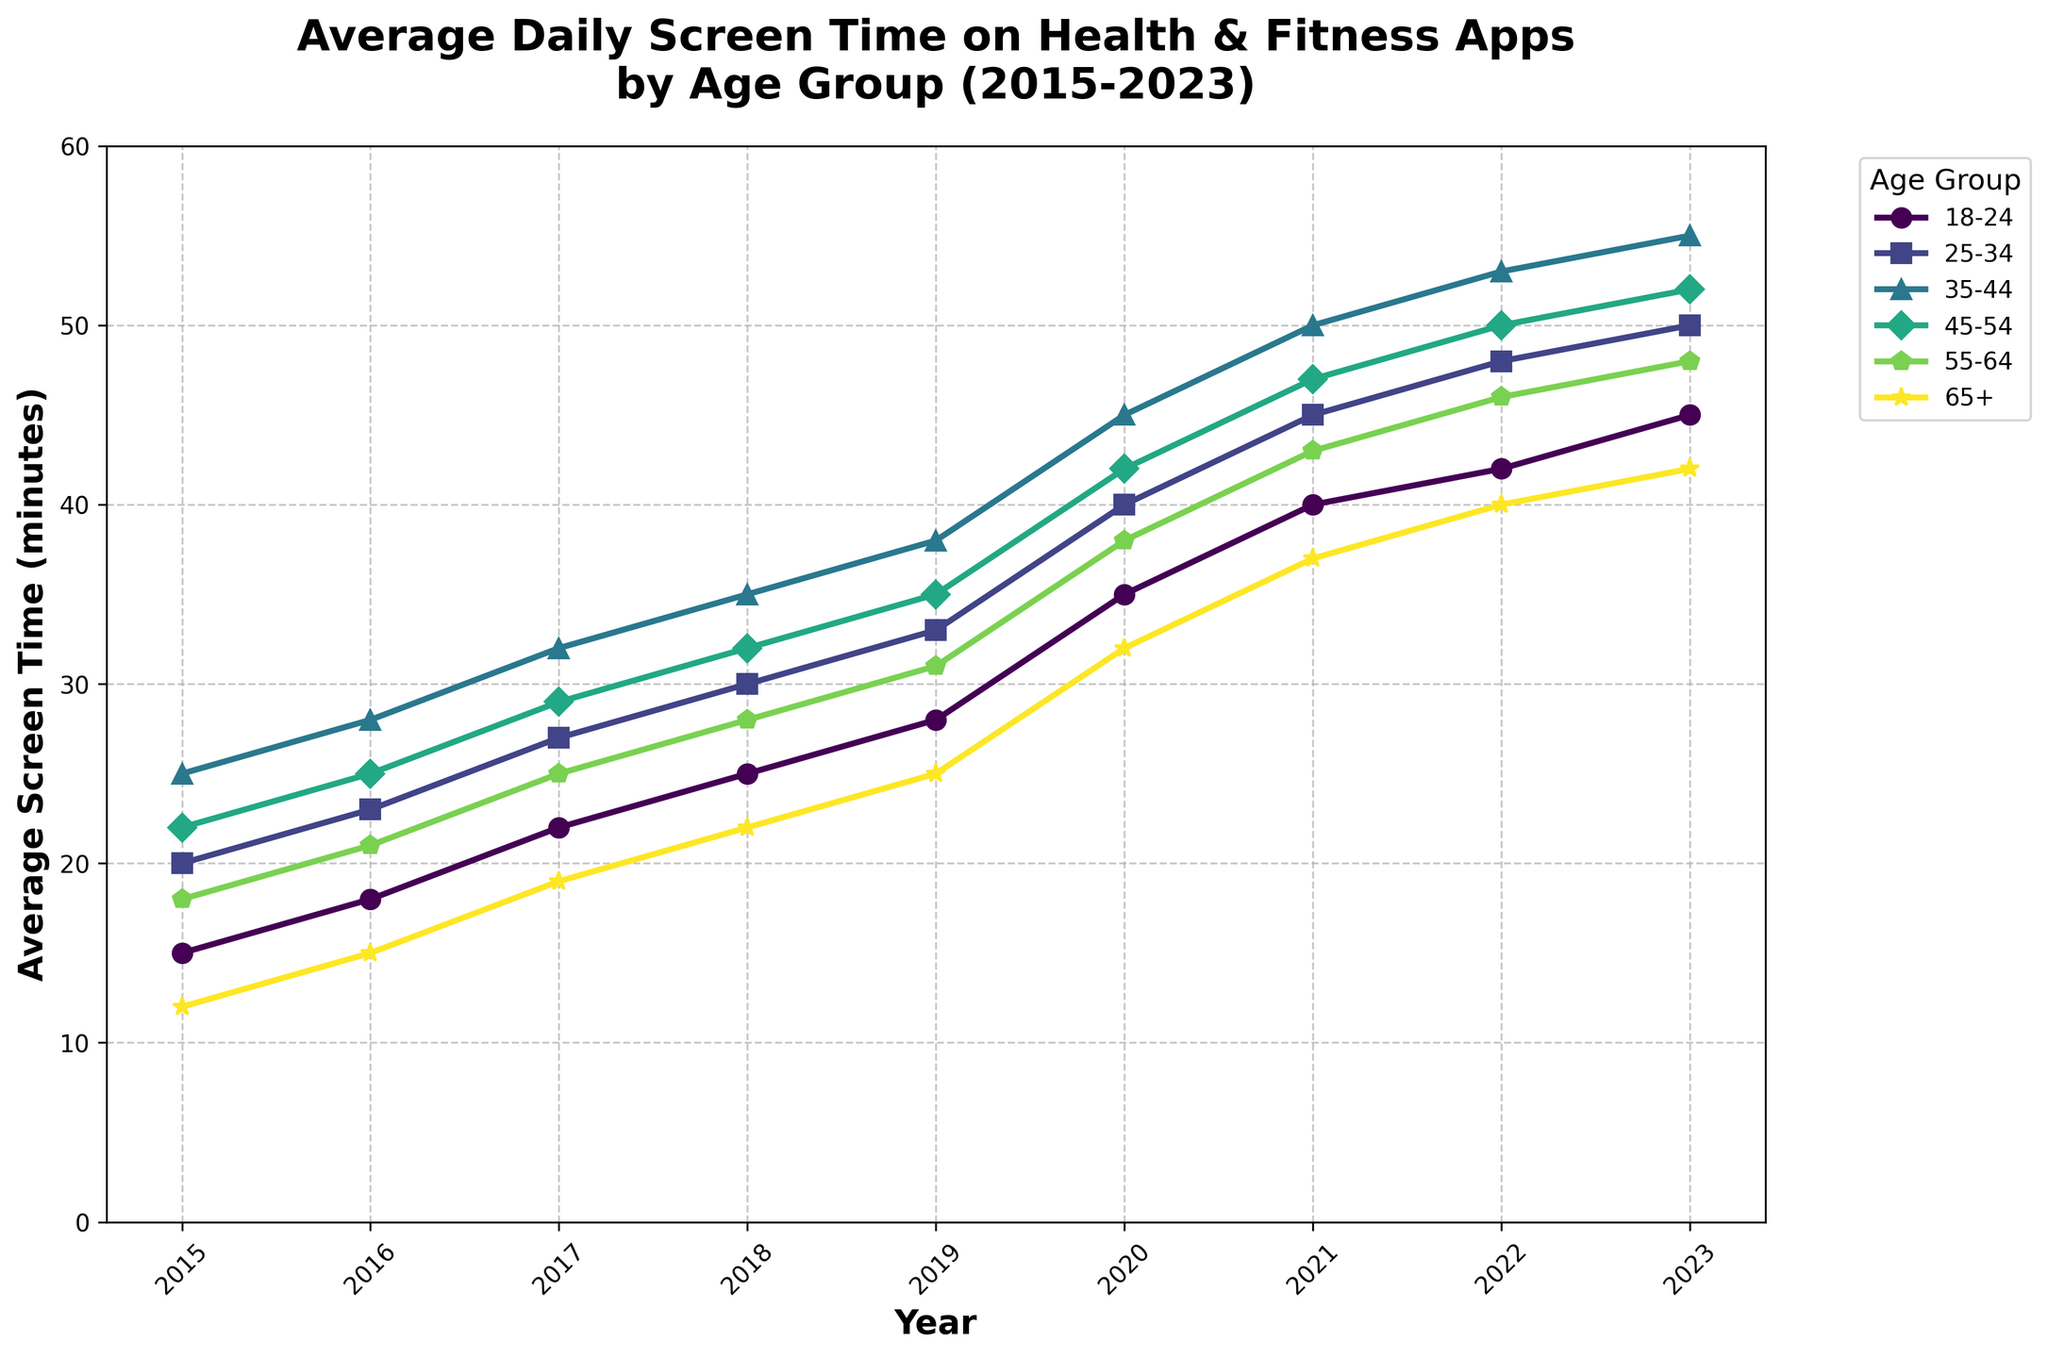What age group saw the highest increase in average screen time from 2015 to 2023? To determine which age group had the highest increase, subtract the 2015 average screen time from the 2023 average screen time for each age group. The age group 35-44 shows an increase from 25 to 55, which is the highest increase of 30 minutes.
Answer: The 35-44 age group Which age group spent the least amount of time on health and fitness apps in 2015? By referring to the 2015 data column, we see that the 65+ age group has the lowest screen time of 12 minutes in 2015.
Answer: The 65+ age group What is the average increase in screen time per year for the 18-24 age group from 2015 to 2023? The increase in screen time from 2015 to 2023 for the 18-24 age group is 45 - 15 = 30 minutes. There are 8 years between 2015 and 2023, so the average increase per year is 30/8 = 3.75 minutes per year.
Answer: 3.75 minutes per year Comparing the trends, which age group’s screen time converged the closest to the 45-54 age group in 2023? In 2023, the screen time for the 45-54 age group is 52 minutes. Among the others, the 55-64 age group at 48 minutes is the closest.
Answer: The 55-64 age group Which age group exhibited the steepest increase in screen time during the year 2020? The 18-24 age group shows an increase from 28 to 35 minutes, which is a 7-minute increase — the steepest among all other groups in the year 2020.
Answer: The 18-24 age group How did the 25-34 age group's screen time change between 2018 and 2022? The screen time for the 25-34 age group increased from 30 minutes in 2018 to 48 minutes in 2022. The change is 48 - 30 = 18 minutes.
Answer: Increased by 18 minutes Which two age groups saw the same increase in average screen time between 2015 and 2016? By comparing the data for 2015 and 2016, both the 18-24 and 55-64 age groups saw an increase of 3 minutes each (from 15 to 18 and from 18 to 21 respectively).
Answer: The 18-24 and 55-64 age groups In 2018, which age group had a screen time closest to the overall average of all age groups in the same year? Sum the screen times for 2018 and divide by the number of age groups: (25+30+35+32+28+22)/6 = 28.67 minutes. The 55-64 age group with 28 minutes is the closest.
Answer: The 55-64 age group Between 2017 and 2019, which age group had the least growth in average screen time? To calculate the growth, subtract the values for 2017 from 2019. The 65+ age group shows the smallest increase from 19 to 25 minutes, which is 6 minutes.
Answer: The 65+ age group Which age group consistently showed an increasing trend in their screen time every year from 2015 to 2023 without any decrease? By analyzing the trends for each age group, the 35-44 age group shows a steady increase every year without any decrease in screen time.
Answer: The 35-44 age group 